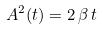<formula> <loc_0><loc_0><loc_500><loc_500>A ^ { 2 } ( t ) = 2 \, \beta \, t</formula> 